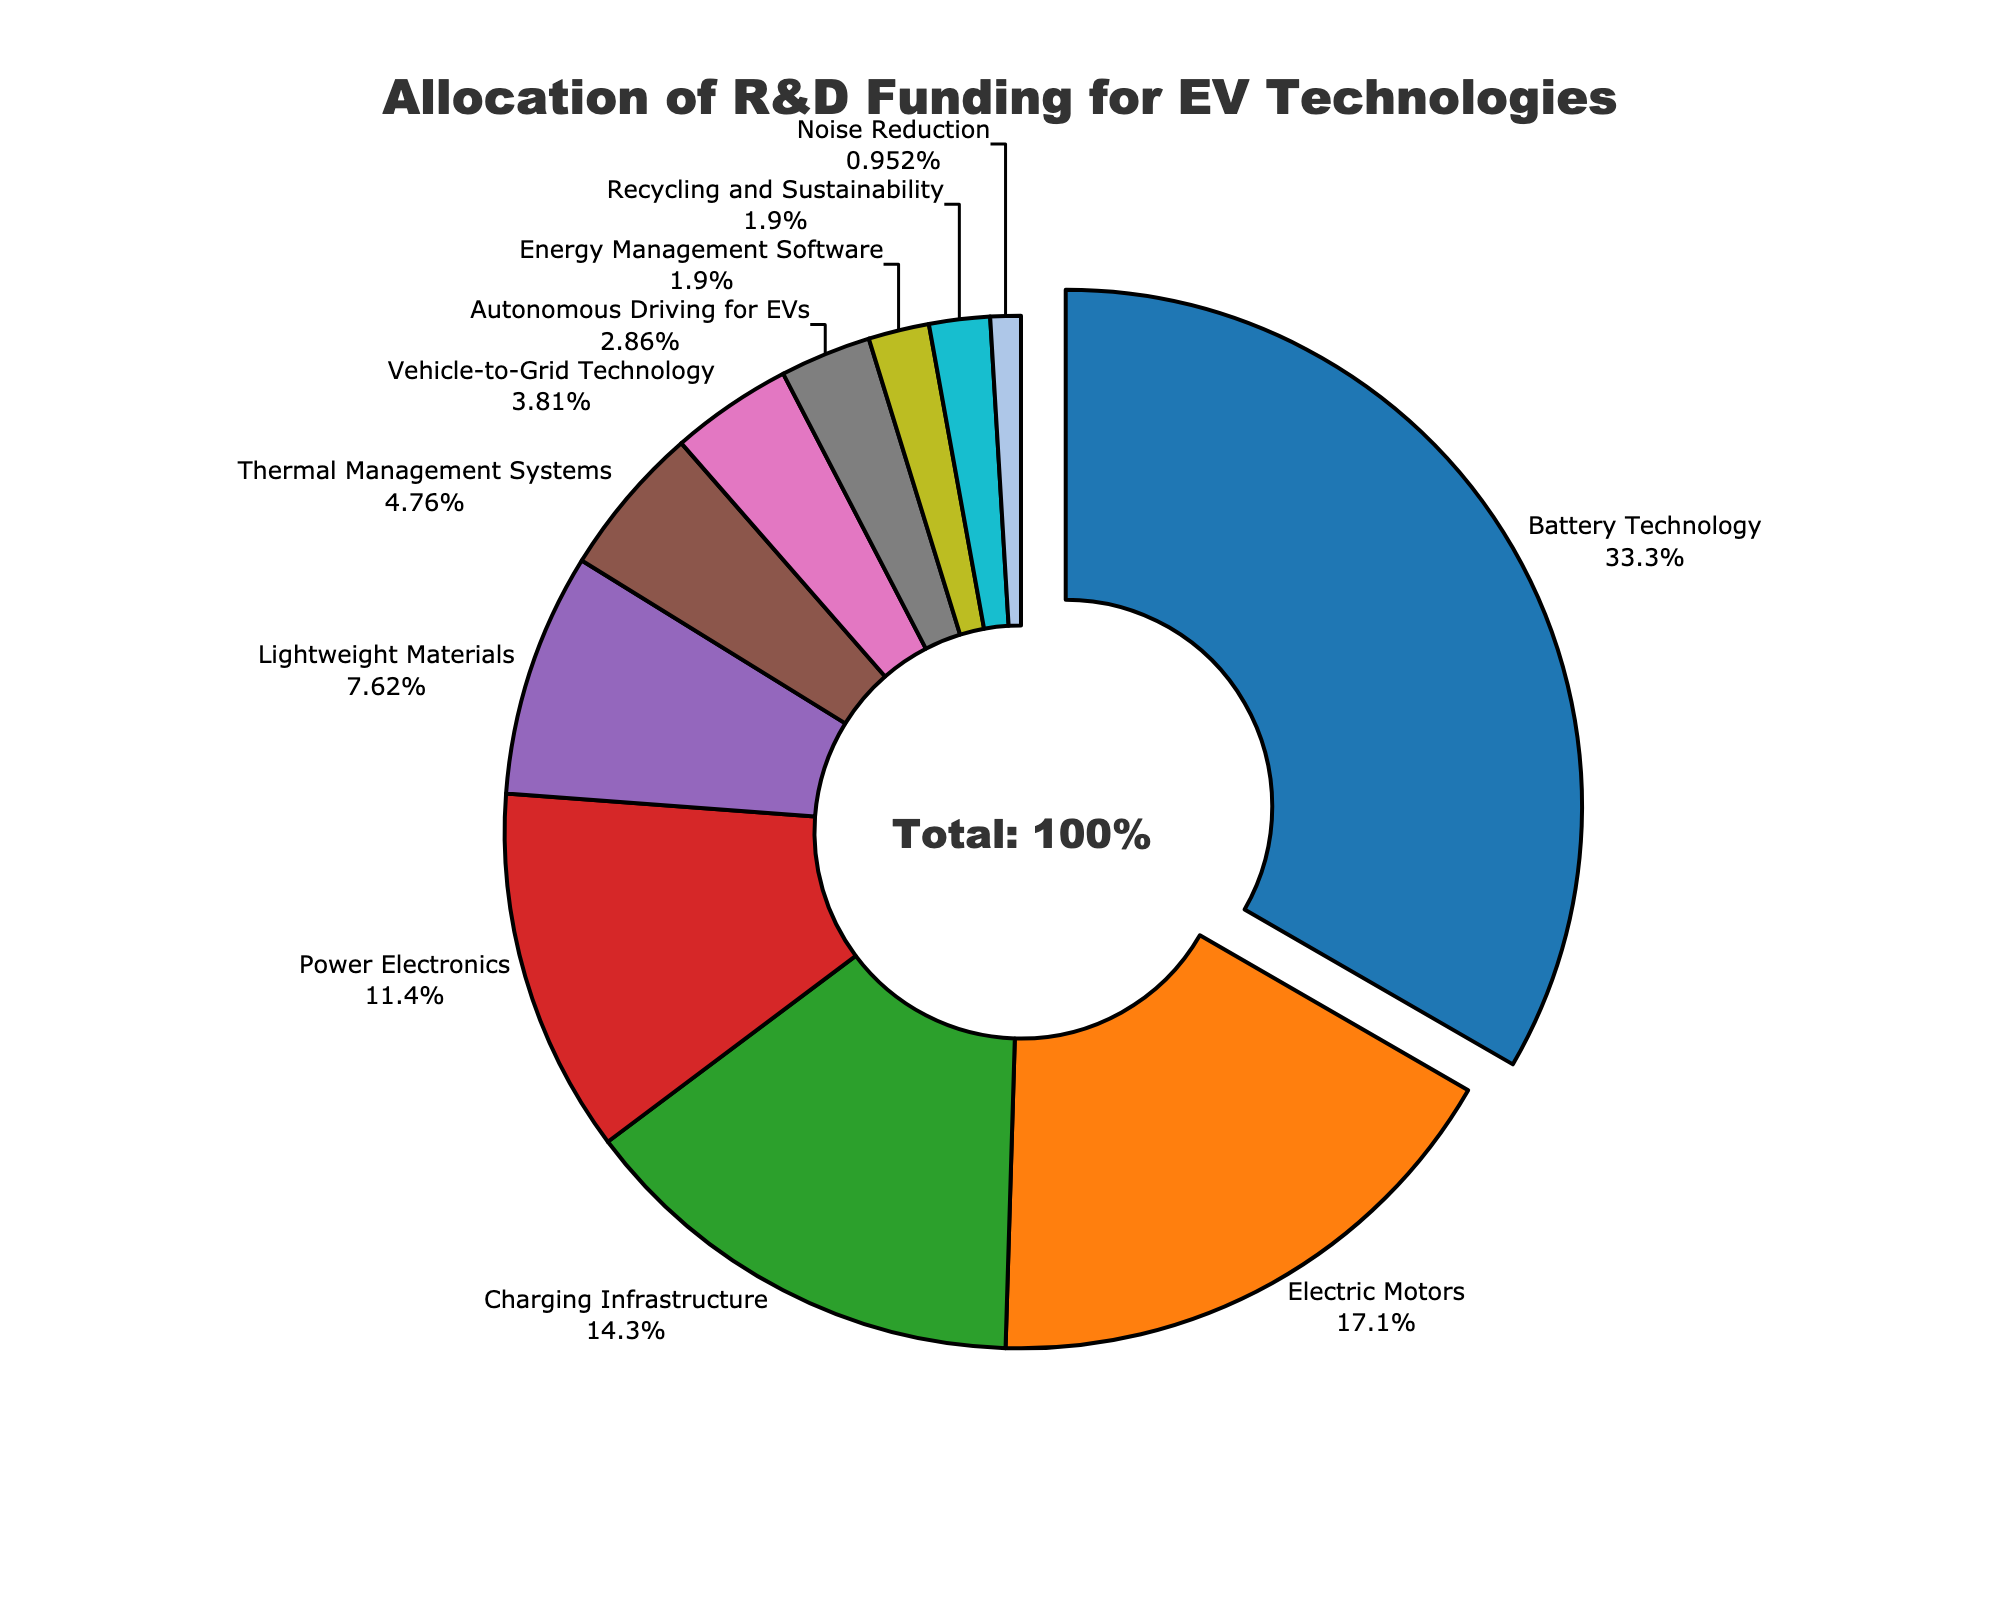What's the largest category of R&D funding allocation? The largest segment of the pie chart is for Battery Technology. This can be identified by both the largest proportion of the chart and the annotation indicating a pull-out segment.
Answer: Battery Technology What's the percentage of total funding allocated to Charging Infrastructure and Power Electronics combined? Combine the percentages for Charging Infrastructure (15%) and Power Electronics (12%). 15% + 12% = 27%
Answer: 27% Which category receives the least funding, and what is its percentage? The smallest segment of the pie chart is labeled as Noise Reduction, with the corresponding percentage shown as 1%.
Answer: Noise Reduction, 1% Is the funding for Electric Motors greater than the funding for Lightweight Materials? Compare the percentages for Electric Motors (18%) and Lightweight Materials (8%). 18% is greater than 8%.
Answer: Yes What proportion of the funding is allocated to categories with percentages lower than 5%? Sum the percentages for Vehicle-to-Grid Technology (4%), Autonomous Driving for EVs (3%), Energy Management Software (2%), Recycling and Sustainability (2%), and Noise Reduction (1%). 4% + 3% + 2% + 2% + 1% = 12%
Answer: 12% Which category of research and development has a pulled-out segment, and why might this be done visually? The pulled-out segment is for Battery Technology. This is often done to highlight the significance of this category, indicating it has the largest allocation of funding.
Answer: Battery Technology, to highlight it Are there more categories with funding allocations above 10% or below 10%? Count the number of categories above 10%: Battery Technology, Electric Motors, Charging Infrastructure, Power Electronics (4 categories). Count the categories below 10%: Lightweight Materials, Thermal Management Systems, Vehicle-to-Grid Technology, Autonomous Driving for EVs, Energy Management Software, Recycling and Sustainability, Noise Reduction (7 categories). There are more categories below 10%.
Answer: Below 10% What is the combined funding allocation for Battery Technology, Electric Motors, and Charging Infrastructure? Add the percentages for Battery Technology (35%), Electric Motors (18%), and Charging Infrastructure (15%). 35% + 18% + 15% = 68%
Answer: 68% How does the funding for Thermal Management Systems compare to Recycling and Sustainability? Compare the percentages for Thermal Management Systems (5%) and Recycling and Sustainability (2%). 5% is greater than 2%.
Answer: Thermal Management Systems has more What percentage of the total funding is allocated to categories that specifically deal with materials (Lightweight Materials, Recycling and Sustainability)? Combine the percentages for Lightweight Materials (8%) and Recycling and Sustainability (2%). 8% + 2% = 10%
Answer: 10% 